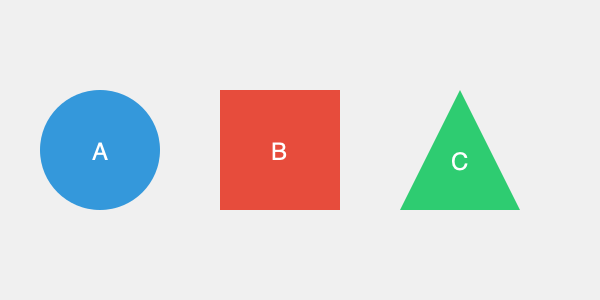Which 3D logo design would be most visually appealing and memorable for a tech startup focused on innovative cloud computing solutions? To determine the most visually appealing and memorable 3D logo design for a tech startup focused on innovative cloud computing solutions, we need to consider several factors:

1. Relevance to the industry:
   - Logo A (circle): Represents continuity and global reach, which aligns with cloud computing.
   - Logo B (square): Symbolizes stability and reliability, but less dynamic.
   - Logo C (triangle): Implies growth and upward movement, relevant to innovation.

2. Simplicity and memorability:
   - All logos are simple shapes, making them easy to remember.
   - The circle (A) is the most basic and universally recognizable.

3. Color psychology:
   - Logo A (blue): Associated with trust, professionalism, and technology.
   - Logo B (red): Energetic but can be seen as aggressive for a tech company.
   - Logo C (green): Represents growth and innovation but less common in tech.

4. Versatility in 3D applications:
   - The sphere (A) is the most versatile 3D shape, looking consistent from all angles.
   - The cube (B) and pyramid (C) may have varying appearances depending on the viewing angle.

5. Modern aesthetic:
   - The sphere (A) has a sleek, modern look that aligns well with contemporary design trends in tech.

Considering these factors, Logo A (the blue sphere) would be the most visually appealing and memorable for a cloud computing tech startup. It combines relevance to the industry, simplicity, appropriate color psychology, versatility in 3D applications, and a modern aesthetic.
Answer: Logo A (blue sphere) 